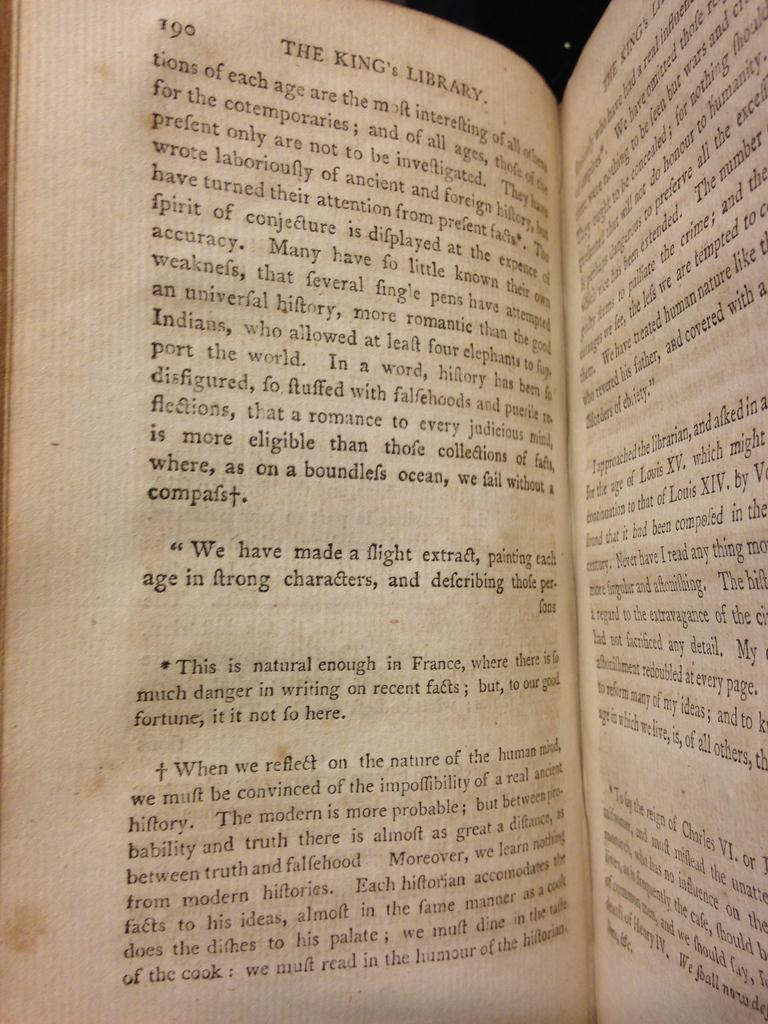Provide a one-sentence caption for the provided image. The King's Library that is opened to page 190. 